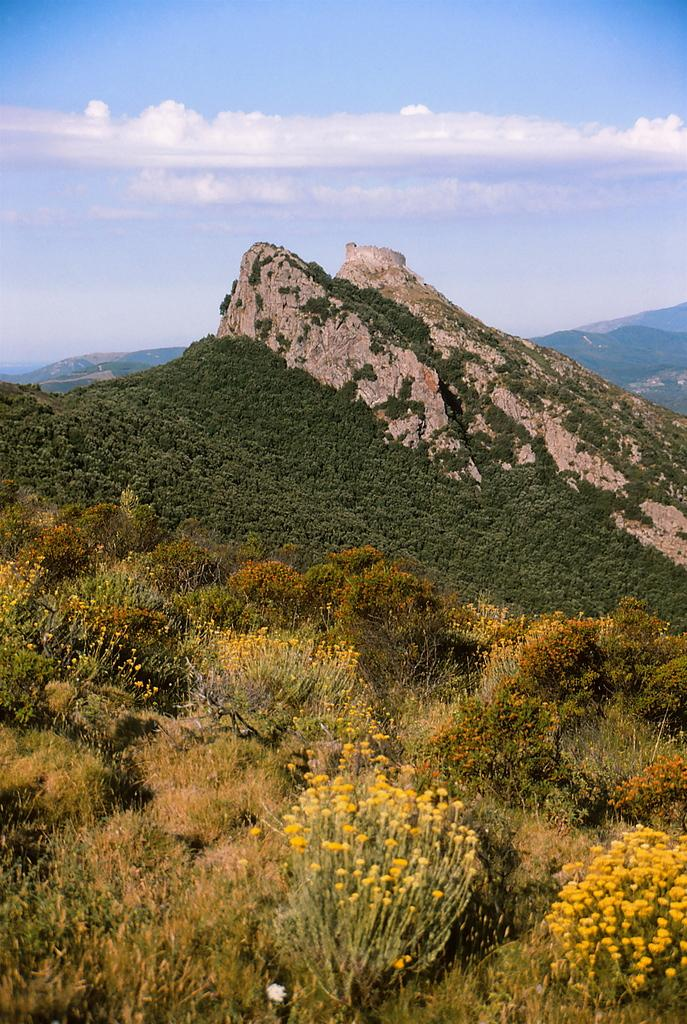What type of living organisms can be seen in the image? Plants can be seen in the image. What colors are present on the plants in the image? The plants have green, yellow, and orange colors. What can be seen in the background of the image? Mountains, trees, and the sky can be seen in the background of the image. What type of argument can be seen taking place between the plants in the image? There is no argument present in the image; it features plants with various colors and a background of mountains, trees, and the sky. 